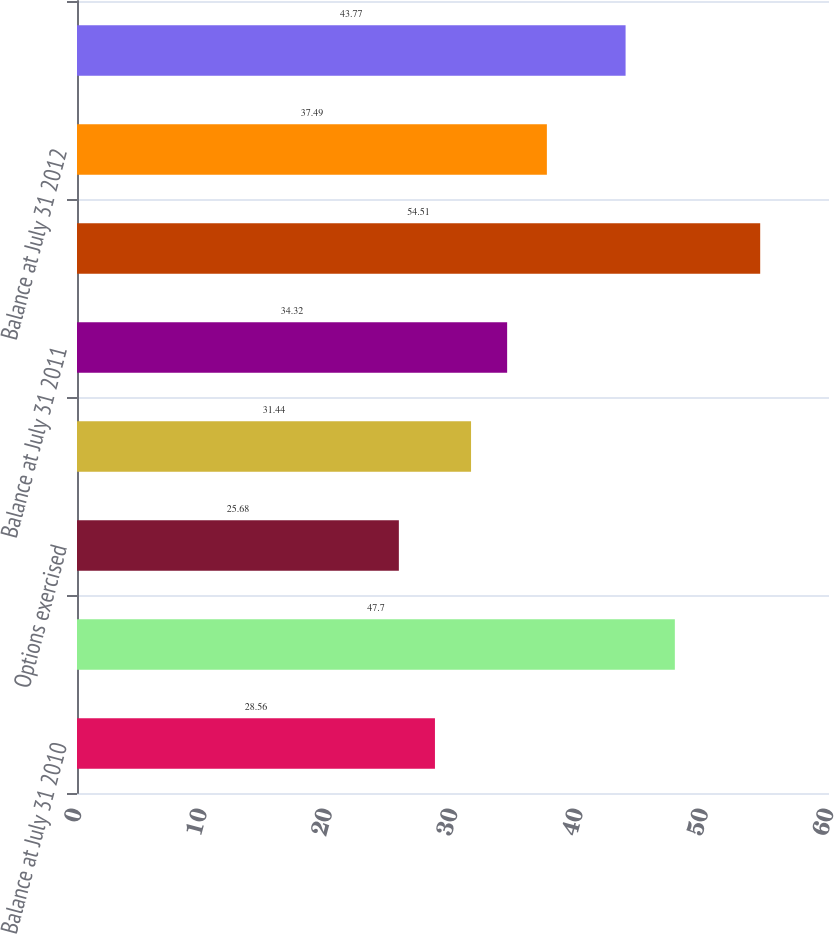Convert chart to OTSL. <chart><loc_0><loc_0><loc_500><loc_500><bar_chart><fcel>Balance at July 31 2010<fcel>Options granted<fcel>Options exercised<fcel>Options canceled or expired<fcel>Balance at July 31 2011<fcel>Options assumed and converted<fcel>Balance at July 31 2012<fcel>Balance at July 31 2013<nl><fcel>28.56<fcel>47.7<fcel>25.68<fcel>31.44<fcel>34.32<fcel>54.51<fcel>37.49<fcel>43.77<nl></chart> 